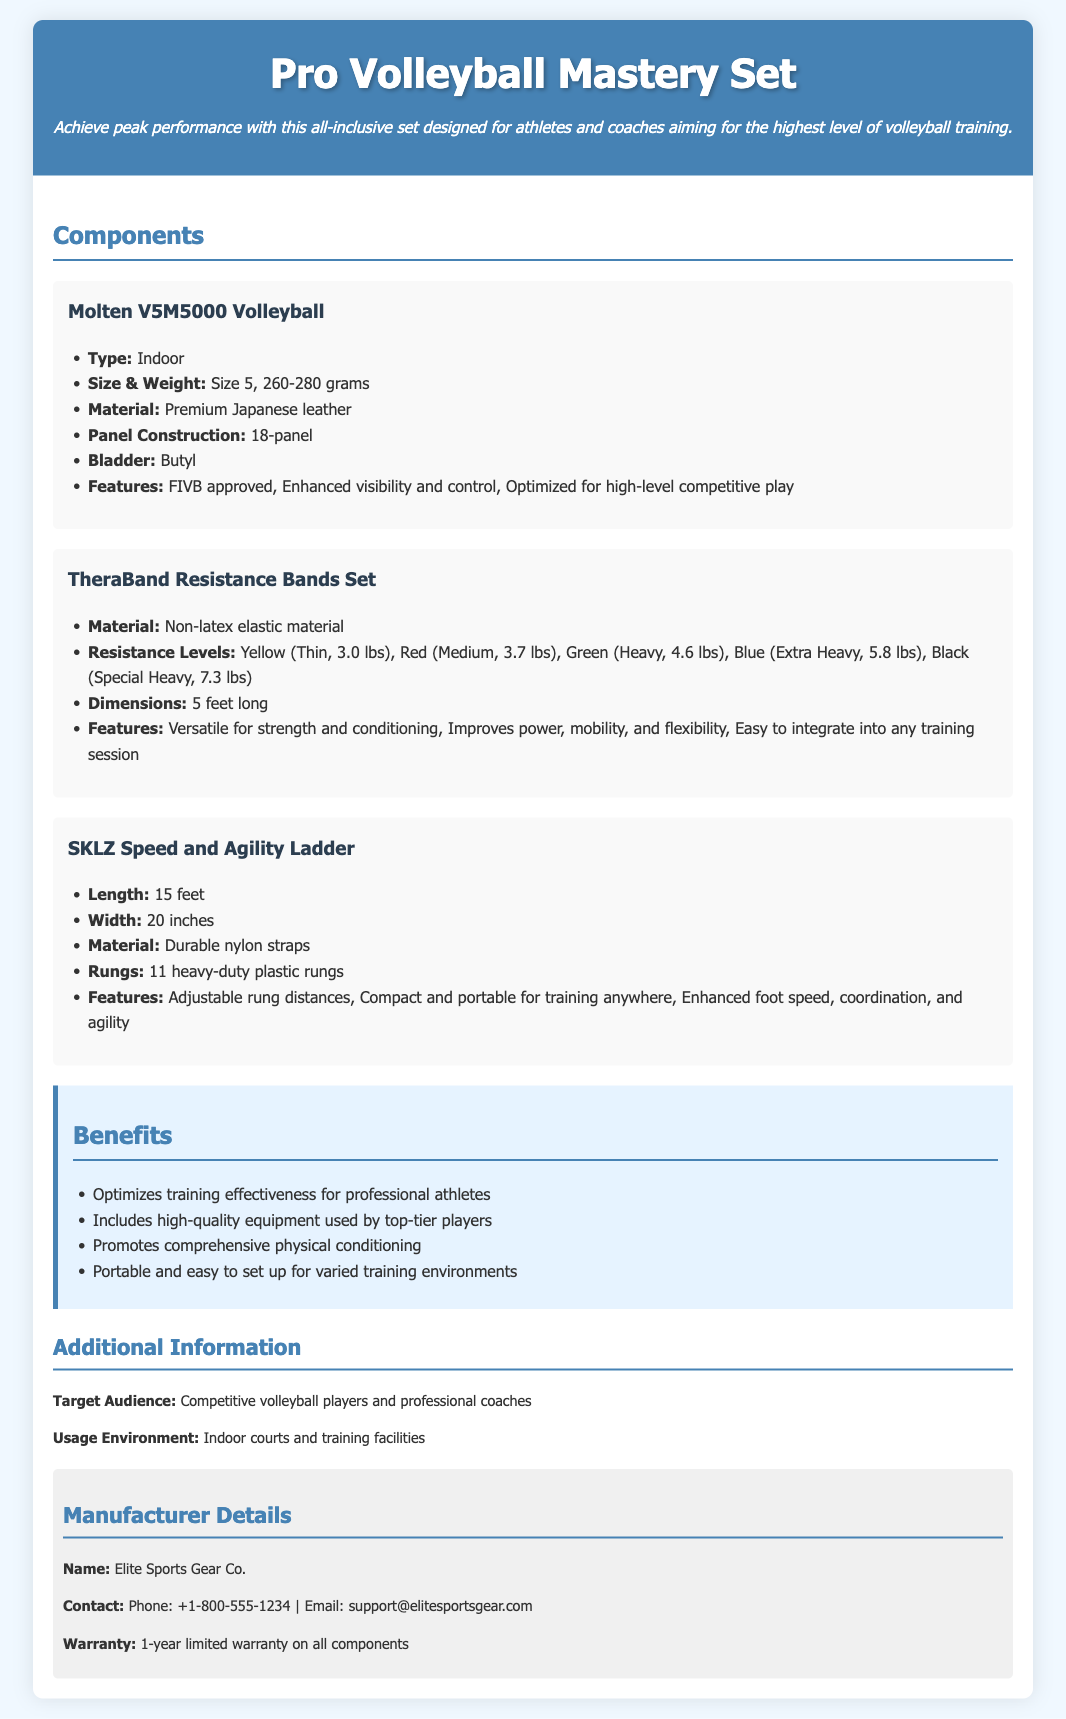what is the type of volleyball included in the set? The document specifies that the volleyball included is of the type Indoor.
Answer: Indoor what is the weight range of the Molten V5M5000 Volleyball? The weight range is provided in the specifications as between 260-280 grams.
Answer: 260-280 grams how many resistance levels are available in the TheraBand Resistance Bands Set? The document lists five distinct resistance levels for the bands.
Answer: Five what material is the SKLZ Speed and Agility Ladder made from? The specifications clearly state that the material used is Durable nylon straps.
Answer: Durable nylon straps what is the length of the agility ladder? The document notes that the length of the agility ladder is 15 feet.
Answer: 15 feet who is the manufacturer of the Pro Volleyball Mastery Set? The document mentions that the manufacturer is Elite Sports Gear Co.
Answer: Elite Sports Gear Co how long is the warranty for the equipment? The warranty information in the document indicates it is a 1-year limited warranty.
Answer: 1-year what benefit does the equipment provide for professional athletes? The benefits section claims that it optimizes training effectiveness for professional athletes.
Answer: Optimizes training effectiveness what are the dimensions of the resistance bands? The document specifies that the resistance bands are 5 feet long.
Answer: 5 feet long 